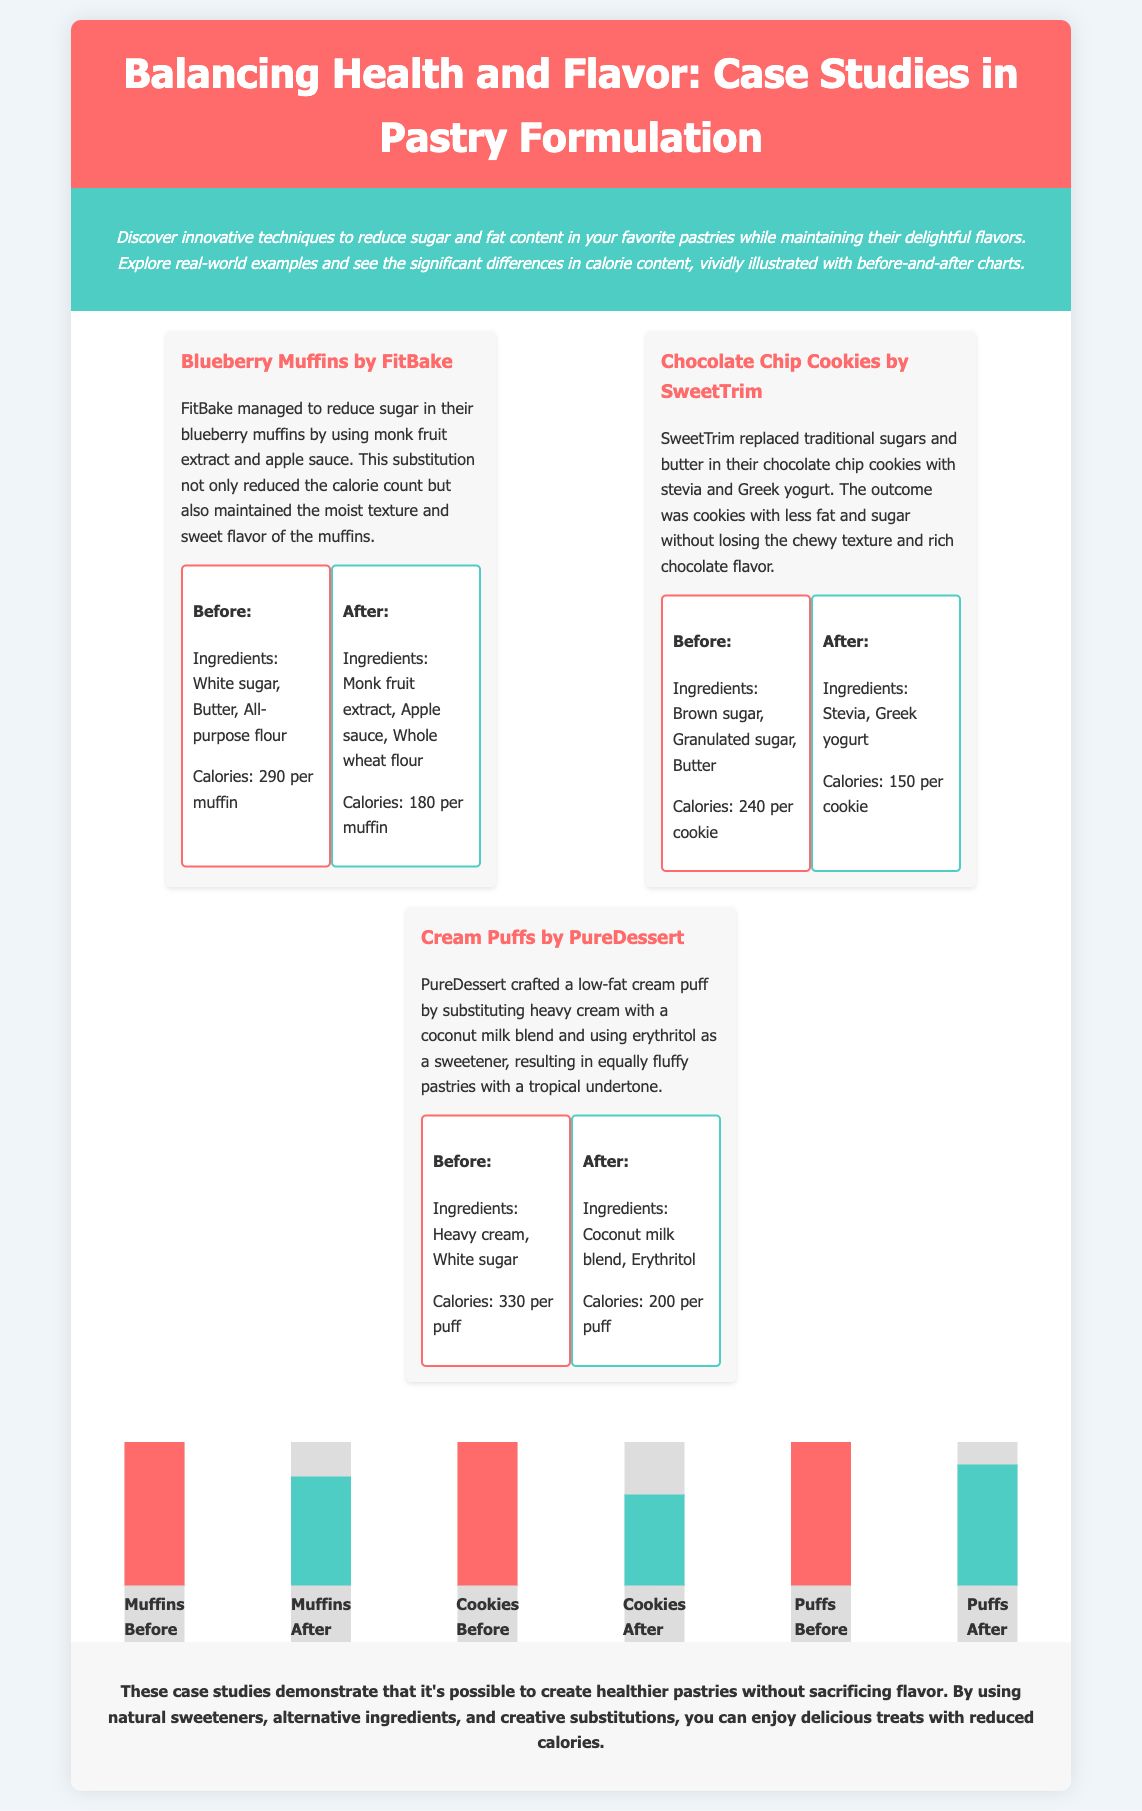What is the title of the document? The title is explicitly stated at the top of the document.
Answer: Balancing Health and Flavor: Case Studies in Pastry Formulation How many case studies are presented in the document? There are three distinct case studies mentioned in the content.
Answer: 3 What was the calorie count for blueberry muffins before the reformulation? The before calorie count for blueberry muffins can be found in the description of the case study.
Answer: 290 per muffin Which sweetener was used in the chocolate chip cookies reformulation? The specific replacement ingredient is identified in the chocolate chip cookies case study.
Answer: Stevia What was the calorie count reduction for the cream puffs? The document provides a before-and-after calorie comparison for the cream puffs.
Answer: 130 calories Which ingredient was used to replace heavy cream in cream puffs? This replacement ingredient is outlined in the description of the cream puffs case study.
Answer: Coconut milk blend In what way did FitBake maintain moisture in their blueberry muffins? The methodology for maintaining moisture is detailed in the blueberry muffins case study.
Answer: Apple sauce What is the purpose of the vivid charts included in the document? The purpose of the charts is mentioned in the introduction of the document.
Answer: To visually illustrate calorie comparisons What is the main theme of the conclusions drawn in the document? The conclusion summarizes the overall findings of the case studies.
Answer: Healthier pastries without sacrificing flavor 